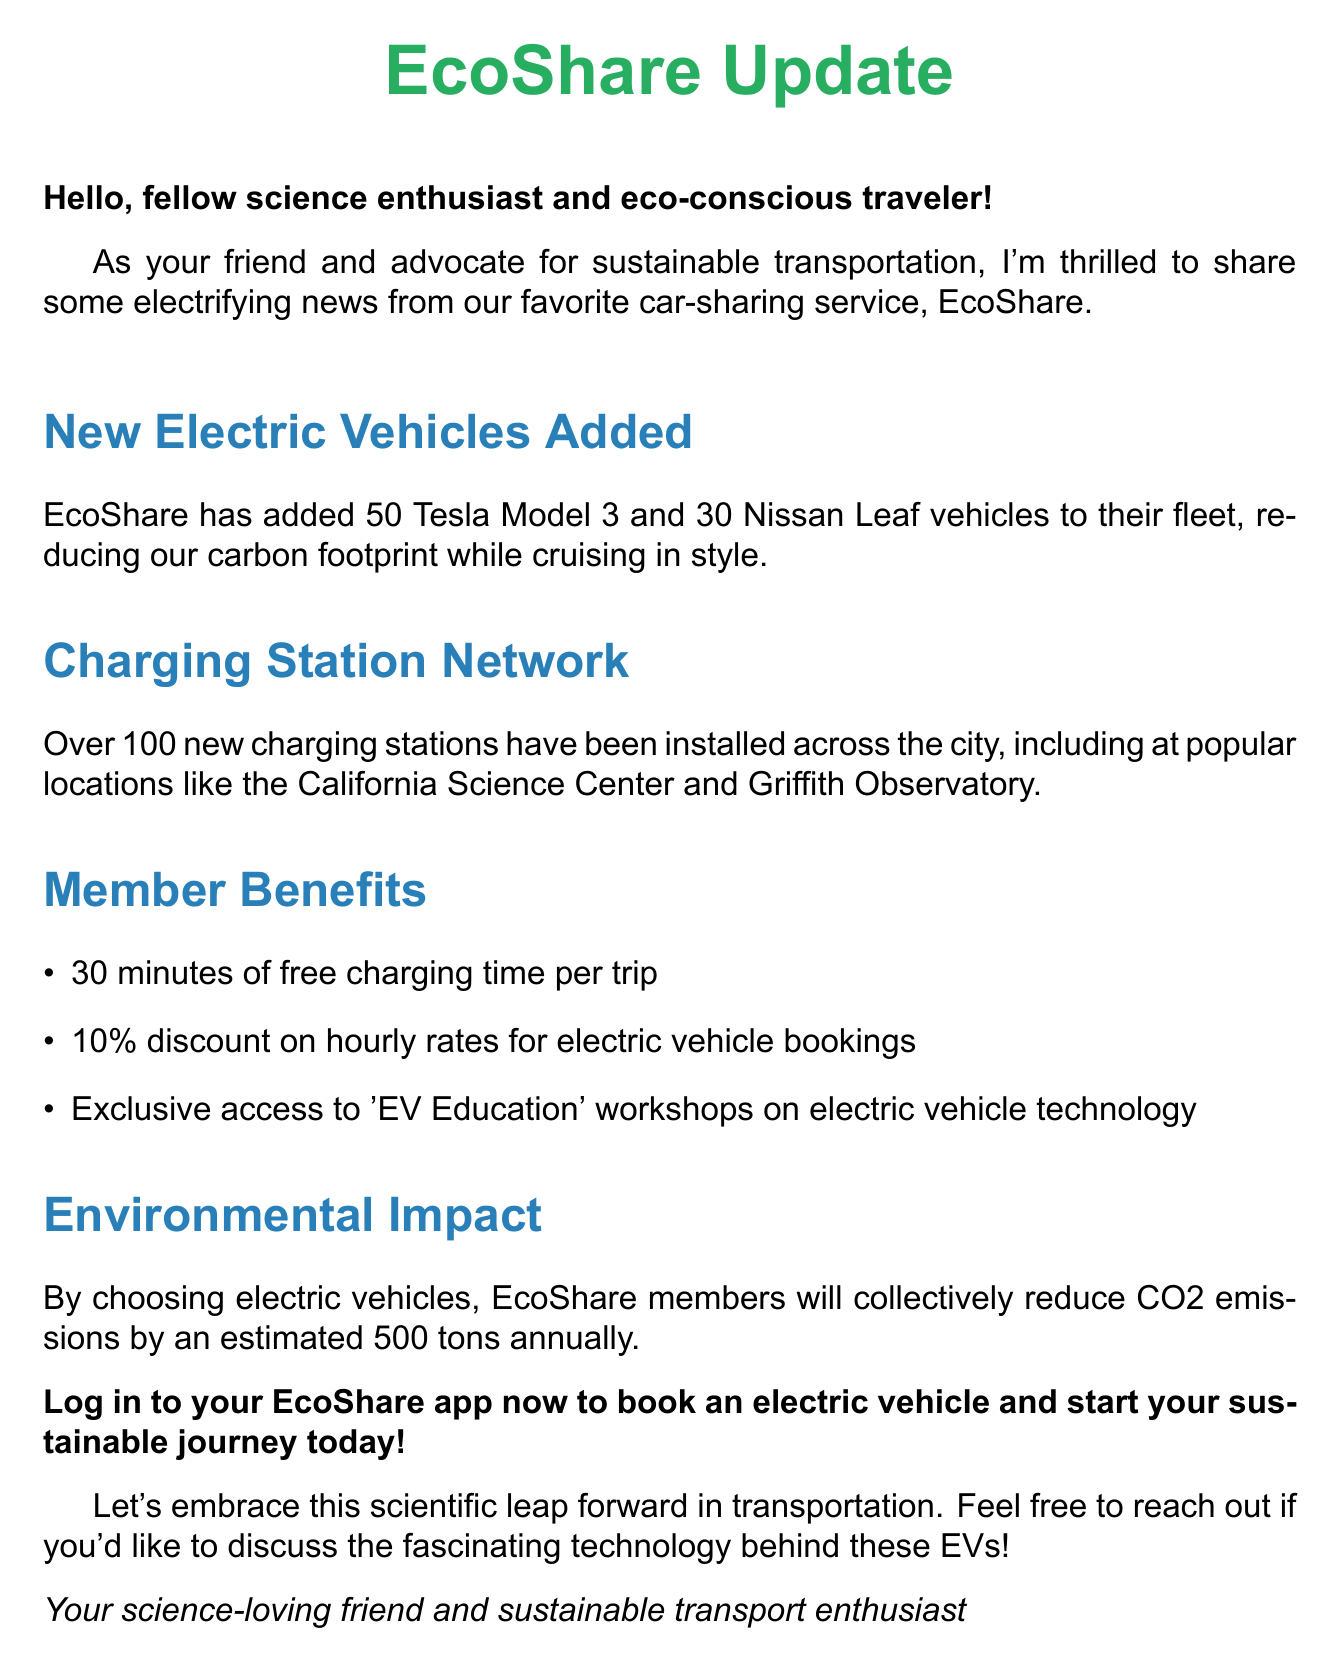What is the total number of new electric vehicles added? The total number of new electric vehicles is the sum of 50 Tesla Model 3 and 30 Nissan Leaf, which equals 80.
Answer: 80 Where can I find new charging stations? The document mentions popular locations where new charging stations have been installed, including the California Science Center and Griffith Observatory.
Answer: California Science Center and Griffith Observatory How much free charging time do members get per trip? The document states that members receive 30 minutes of free charging time per trip.
Answer: 30 minutes What is the percentage discount on hourly rates for electric vehicle bookings? The document specifically mentions a 10% discount available for this type of booking.
Answer: 10% How many tons of CO2 emissions will members collectively reduce annually? The estimate provided in the document states that members will reduce CO2 emissions by 500 tons each year.
Answer: 500 tons What type of workshops are available exclusively to members? The document states that exclusive access is provided for 'EV Education' workshops on electric vehicle technology.
Answer: EV Education workshops What is the primary purpose of the document? The document aims to inform and excite members about the expansion of EcoShare's fleet with electric vehicles and associated benefits.
Answer: Inform and excite members What should I do to book an electric vehicle? The document encourages members to log in to their EcoShare app to book an electric vehicle.
Answer: Log in to your EcoShare app 